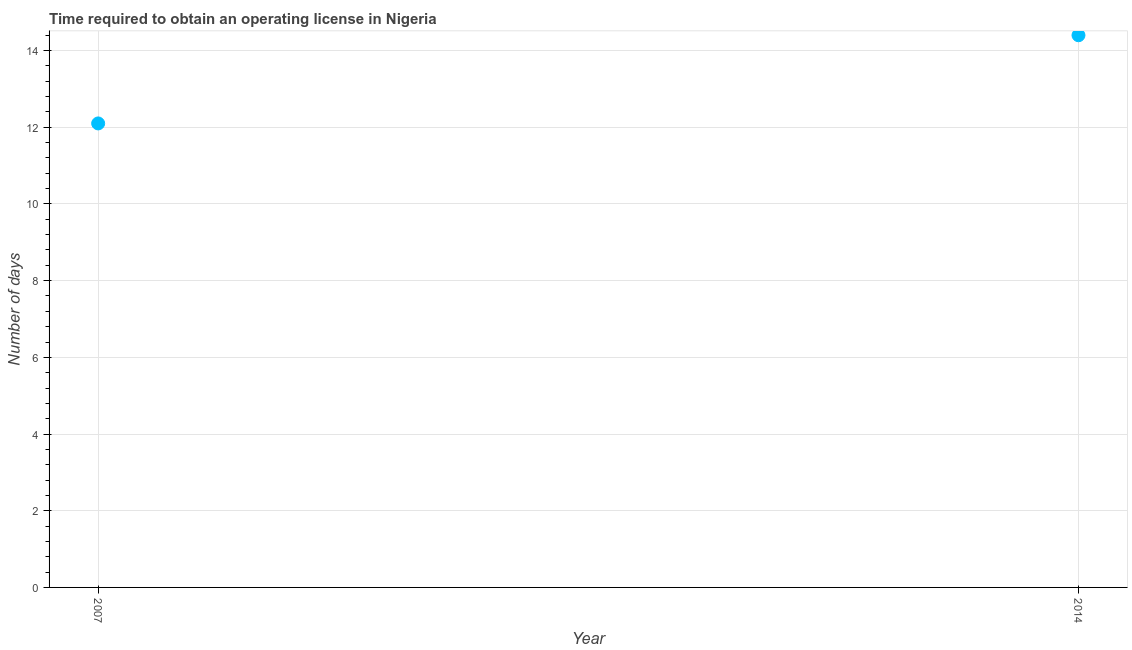What is the number of days to obtain operating license in 2014?
Make the answer very short. 14.4. Across all years, what is the maximum number of days to obtain operating license?
Give a very brief answer. 14.4. In which year was the number of days to obtain operating license maximum?
Ensure brevity in your answer.  2014. In which year was the number of days to obtain operating license minimum?
Your response must be concise. 2007. What is the difference between the number of days to obtain operating license in 2007 and 2014?
Offer a terse response. -2.3. What is the average number of days to obtain operating license per year?
Keep it short and to the point. 13.25. What is the median number of days to obtain operating license?
Keep it short and to the point. 13.25. Do a majority of the years between 2007 and 2014 (inclusive) have number of days to obtain operating license greater than 10.4 days?
Your answer should be compact. Yes. What is the ratio of the number of days to obtain operating license in 2007 to that in 2014?
Your answer should be compact. 0.84. In how many years, is the number of days to obtain operating license greater than the average number of days to obtain operating license taken over all years?
Offer a terse response. 1. Does the number of days to obtain operating license monotonically increase over the years?
Make the answer very short. Yes. How many years are there in the graph?
Give a very brief answer. 2. Are the values on the major ticks of Y-axis written in scientific E-notation?
Make the answer very short. No. Does the graph contain any zero values?
Offer a very short reply. No. Does the graph contain grids?
Give a very brief answer. Yes. What is the title of the graph?
Give a very brief answer. Time required to obtain an operating license in Nigeria. What is the label or title of the X-axis?
Keep it short and to the point. Year. What is the label or title of the Y-axis?
Your answer should be very brief. Number of days. What is the Number of days in 2014?
Your answer should be compact. 14.4. What is the difference between the Number of days in 2007 and 2014?
Your answer should be compact. -2.3. What is the ratio of the Number of days in 2007 to that in 2014?
Keep it short and to the point. 0.84. 